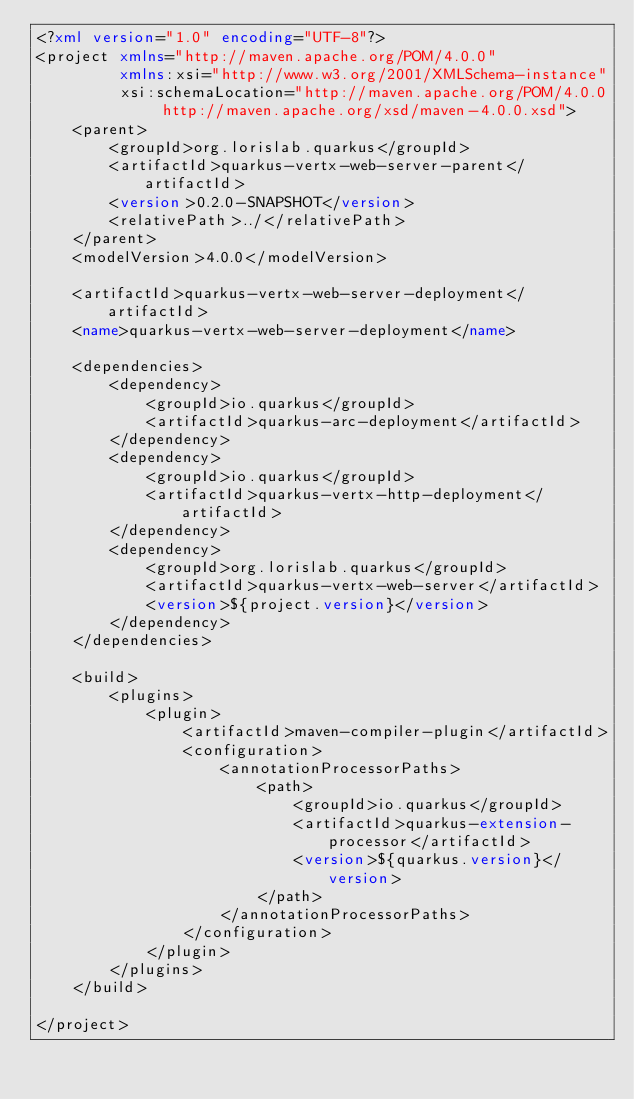Convert code to text. <code><loc_0><loc_0><loc_500><loc_500><_XML_><?xml version="1.0" encoding="UTF-8"?>
<project xmlns="http://maven.apache.org/POM/4.0.0"
         xmlns:xsi="http://www.w3.org/2001/XMLSchema-instance"
         xsi:schemaLocation="http://maven.apache.org/POM/4.0.0 http://maven.apache.org/xsd/maven-4.0.0.xsd">
    <parent>
        <groupId>org.lorislab.quarkus</groupId>
        <artifactId>quarkus-vertx-web-server-parent</artifactId>
        <version>0.2.0-SNAPSHOT</version>
        <relativePath>../</relativePath>
    </parent>
    <modelVersion>4.0.0</modelVersion>

    <artifactId>quarkus-vertx-web-server-deployment</artifactId>
    <name>quarkus-vertx-web-server-deployment</name>

    <dependencies>
        <dependency>
            <groupId>io.quarkus</groupId>
            <artifactId>quarkus-arc-deployment</artifactId>
        </dependency>
        <dependency>
            <groupId>io.quarkus</groupId>
            <artifactId>quarkus-vertx-http-deployment</artifactId>
        </dependency>        
        <dependency>
            <groupId>org.lorislab.quarkus</groupId>
            <artifactId>quarkus-vertx-web-server</artifactId>
            <version>${project.version}</version>
        </dependency>
    </dependencies>

    <build>
        <plugins>
            <plugin>
                <artifactId>maven-compiler-plugin</artifactId>
                <configuration>
                    <annotationProcessorPaths>
                        <path>
                            <groupId>io.quarkus</groupId>
                            <artifactId>quarkus-extension-processor</artifactId>
                            <version>${quarkus.version}</version>
                        </path>
                    </annotationProcessorPaths>
                </configuration>
            </plugin>
        </plugins>
    </build>

</project>
</code> 